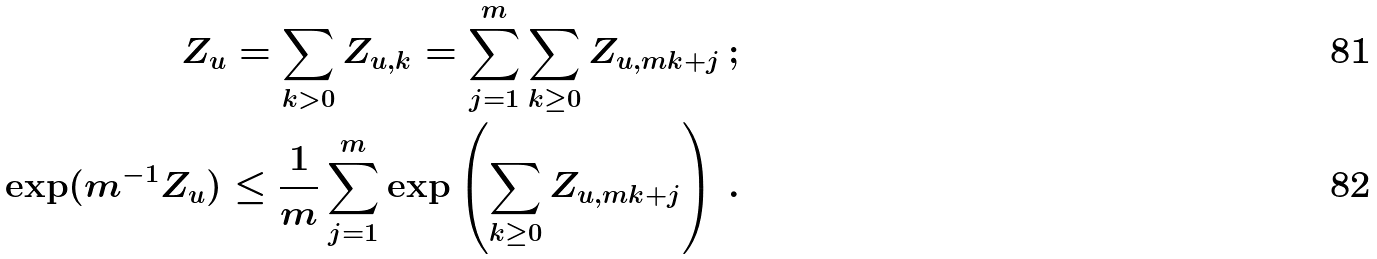Convert formula to latex. <formula><loc_0><loc_0><loc_500><loc_500>Z _ { u } = \sum _ { k > 0 } Z _ { u , k } = \sum _ { j = 1 } ^ { m } \sum _ { k \geq 0 } Z _ { u , m k + j } \, ; \\ \exp ( m ^ { - 1 } Z _ { u } ) \leq \frac { 1 } { m } \sum _ { j = 1 } ^ { m } \exp \left ( \sum _ { k \geq 0 } Z _ { u , m k + j } \right ) \, .</formula> 